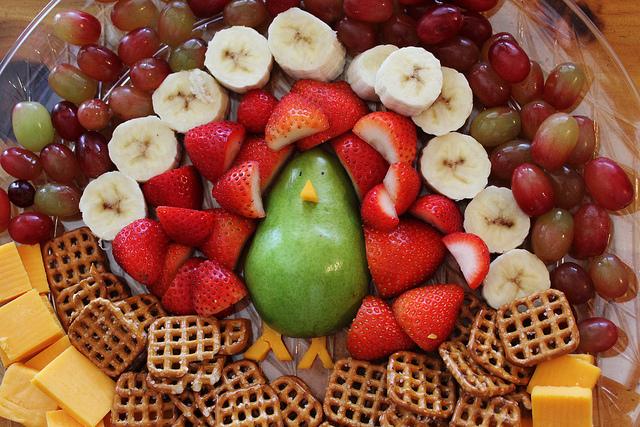How many bananas slices are there?
Concise answer only. 11. What is under the fruit?
Short answer required. Plate. Is there cheese on the plate?
Short answer required. Yes. What is the pear made to look like?
Be succinct. Bird. What is pictured here?
Write a very short answer. Fruit. 